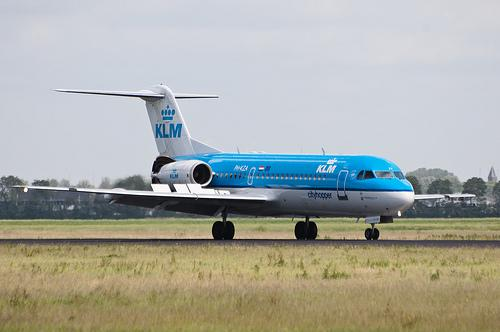Question: what colors is the plane?
Choices:
A. White.
B. Blue and white.
C. Black.
D. Blue.
Answer with the letter. Answer: B Question: what letters are the tail of the plane?
Choices:
A. Aa.
B. KLM.
C. Da.
D. Ba.
Answer with the letter. Answer: B Question: how is the weather?
Choices:
A. Sunny.
B. Cloudy.
C. Windy.
D. Snowy.
Answer with the letter. Answer: B Question: what is in the background?
Choices:
A. Bushes.
B. Buildings.
C. Trees.
D. A lake.
Answer with the letter. Answer: C 